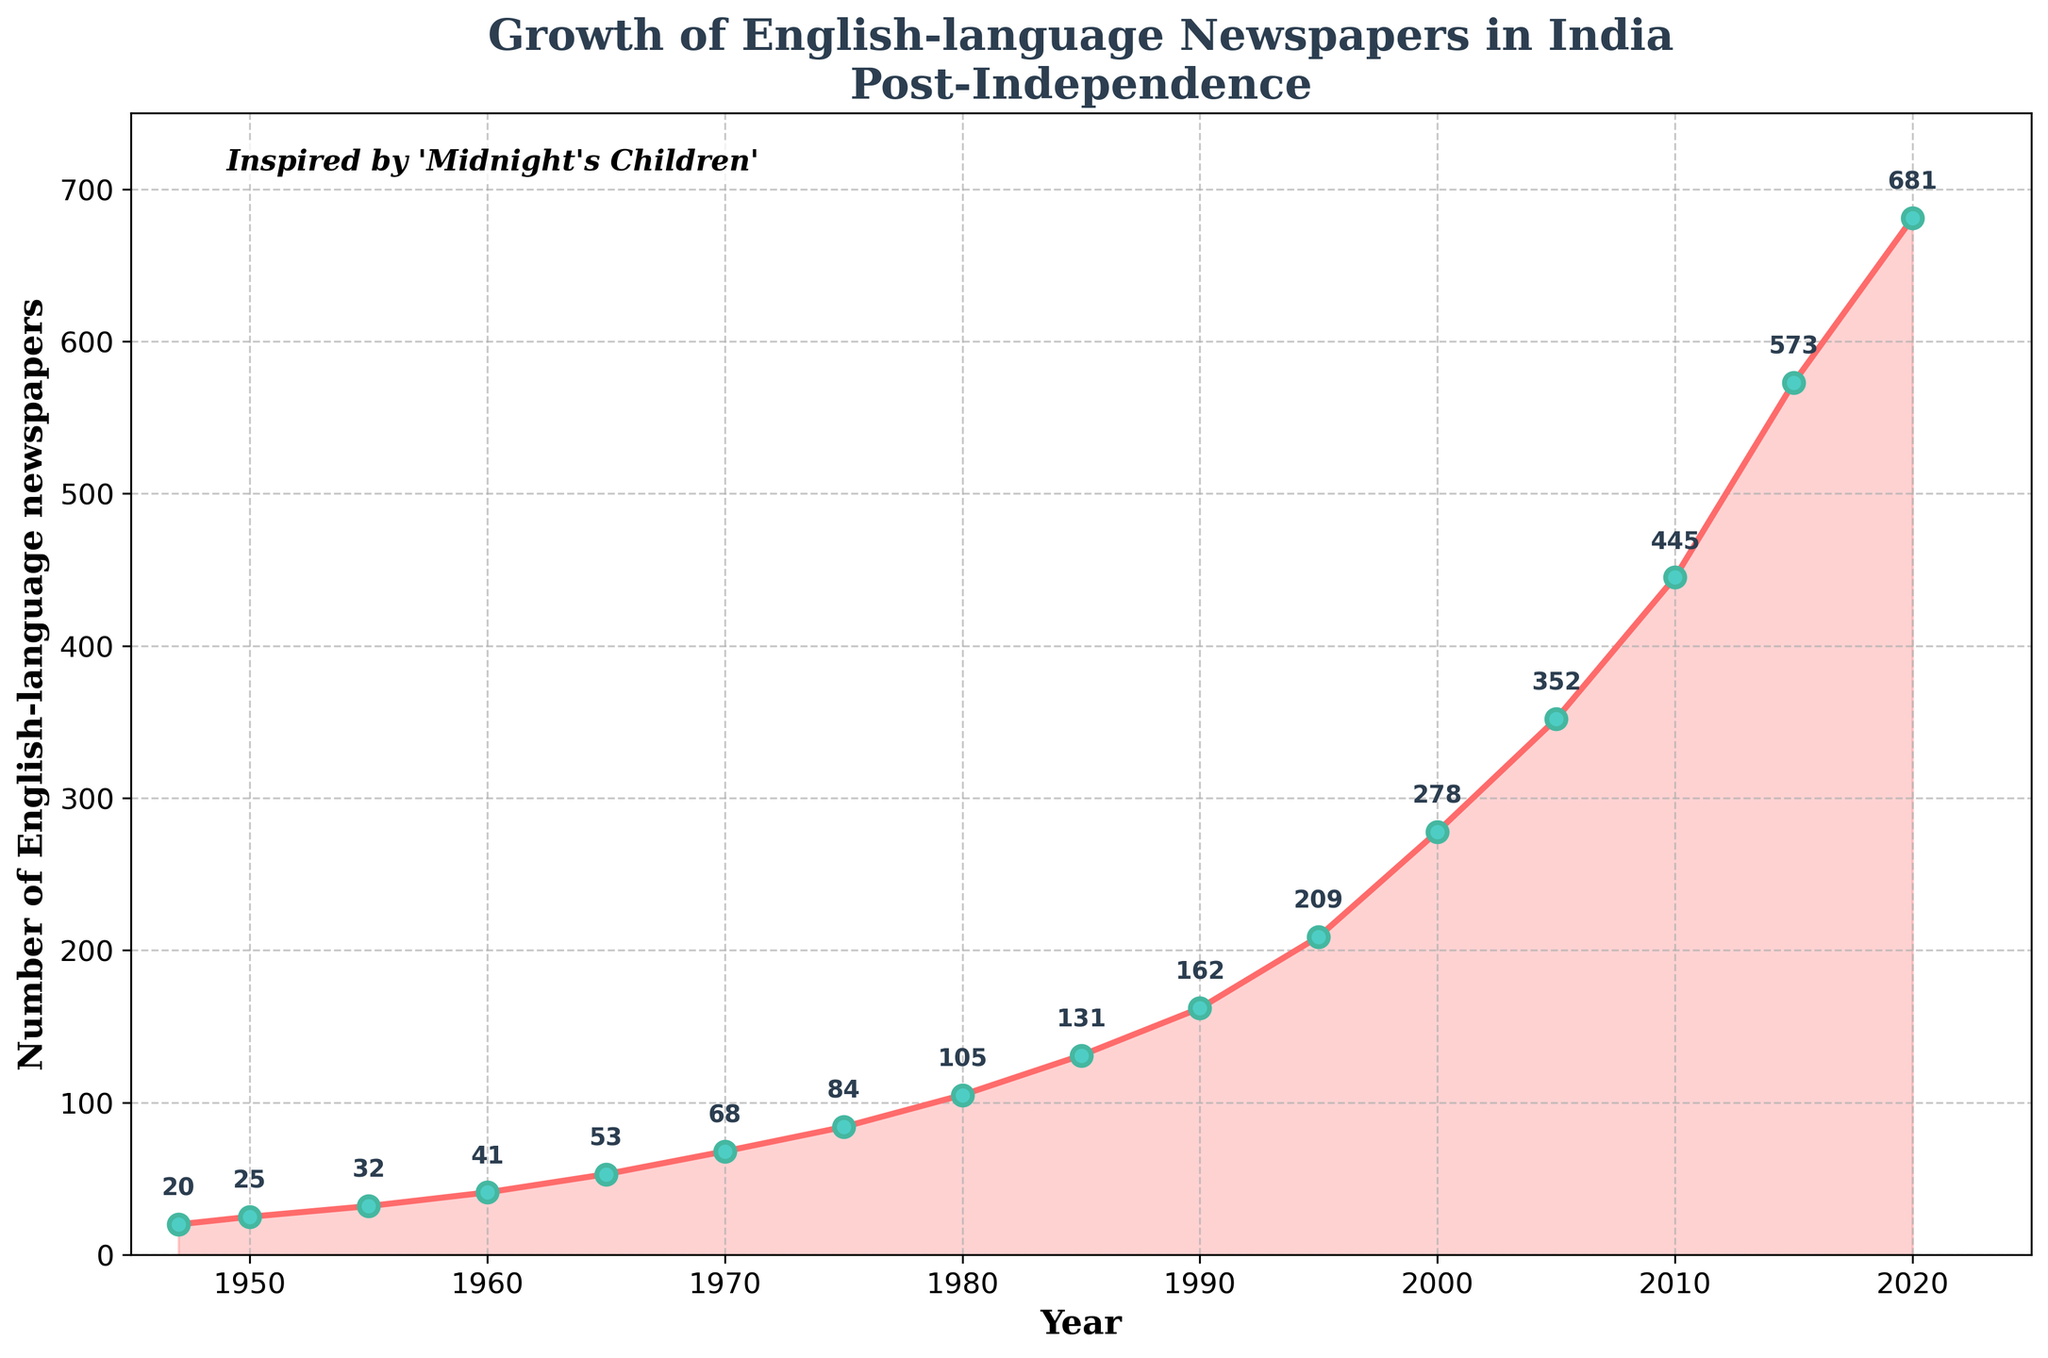What's the general trend in the number of English-language newspapers in India since 1947? To determine the general trend, observe the plotted data points and the connecting line that moves upward from 1947 to 2020, demonstrating a consistent increase.
Answer: Increasing trend What was the approximate number of English-language newspapers in 2020? Locate the year 2020 on the x-axis and find the corresponding data point on the line chart which has been annotated with the value.
Answer: 681 How did the number of English-language newspapers change between 1950 and 1970? Identify the number of newspapers in 1950 (25) and in 1970 (68), then compute the difference, which is 68 - 25.
Answer: Increased by 43 During which decade did the number of newspapers grow by over 100? Review the annotations at each decade interval: notable growths occur from 1980 (105) to 1990 (162) and from 2000 (278) to 2010 (445), representing a growth of 57 and 167 respectively.
Answer: 2000s What was the rate of growth in the number of newspapers from 1947 to 1955? Find the number of newspapers in 1947 (20) and 1955 (32), then calculate the annual growth rate over 8 years: (32 - 20) / 8 = 1.5 newspapers per year.
Answer: 1.5 per year Compare the increase in number of newspapers from 1980 to 1990 with the increase from 1990 to 2000. Which period saw a greater increase? Evaluate the increases: from 1980 (105) to 1990 (162) the increase is 57; from 1990 (162) to 2000 (278) the increase is 116.
Answer: 1990 to 2000 In which year did the number of English-language newspapers first exceed 100? Identify the year at which the annotation first reads over 100, which happens between 1975 and 1980.
Answer: 1980 Calculate the average number of newspapers for the decades 1950-1960 and 2000-2010. Which decade had a higher average? For 1950-1960: (25 + 32 + 41) / 3 = 32.67. For 2000-2010: (278 + 352 + 445) / 3 = 358.33. Compare the values for each period.
Answer: 2000-2010 Describe the visual markers used for the data points in the plot. The data points are marked with circles that are filled with green color, outlined with light green, and are connected with a pinkish-red line.
Answer: Green-filled circles, pinkish-red line Determine the period with the slowest growth in the number of newspapers Evaluate each interval's growth: slowest growth occurred from 1947 (20) to 1950 (25), analyzing changes every successive year range.
Answer: 1947 to 1950 Which year saw the most pronounced increase in newspaper numbers from its previous recorded point? Compare each year-to-year increase, finding the greatest difference. The largest increase is observed from 2015 (573) to 2020 (681), an increase of 108.
Answer: 2015 to 2020 